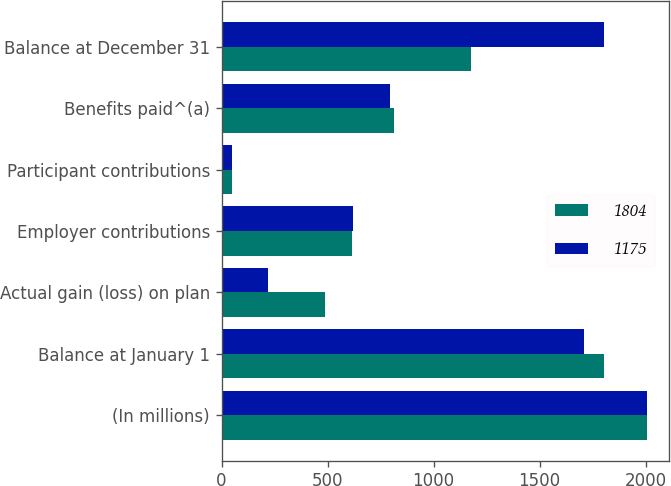Convert chart. <chart><loc_0><loc_0><loc_500><loc_500><stacked_bar_chart><ecel><fcel>(In millions)<fcel>Balance at January 1<fcel>Actual gain (loss) on plan<fcel>Employer contributions<fcel>Participant contributions<fcel>Benefits paid^(a)<fcel>Balance at December 31<nl><fcel>1804<fcel>2008<fcel>1804<fcel>486<fcel>617<fcel>51<fcel>811<fcel>1175<nl><fcel>1175<fcel>2007<fcel>1710<fcel>221<fcel>622<fcel>47<fcel>796<fcel>1804<nl></chart> 